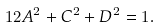<formula> <loc_0><loc_0><loc_500><loc_500>1 2 A ^ { 2 } + C ^ { 2 } + D ^ { 2 } = 1 .</formula> 